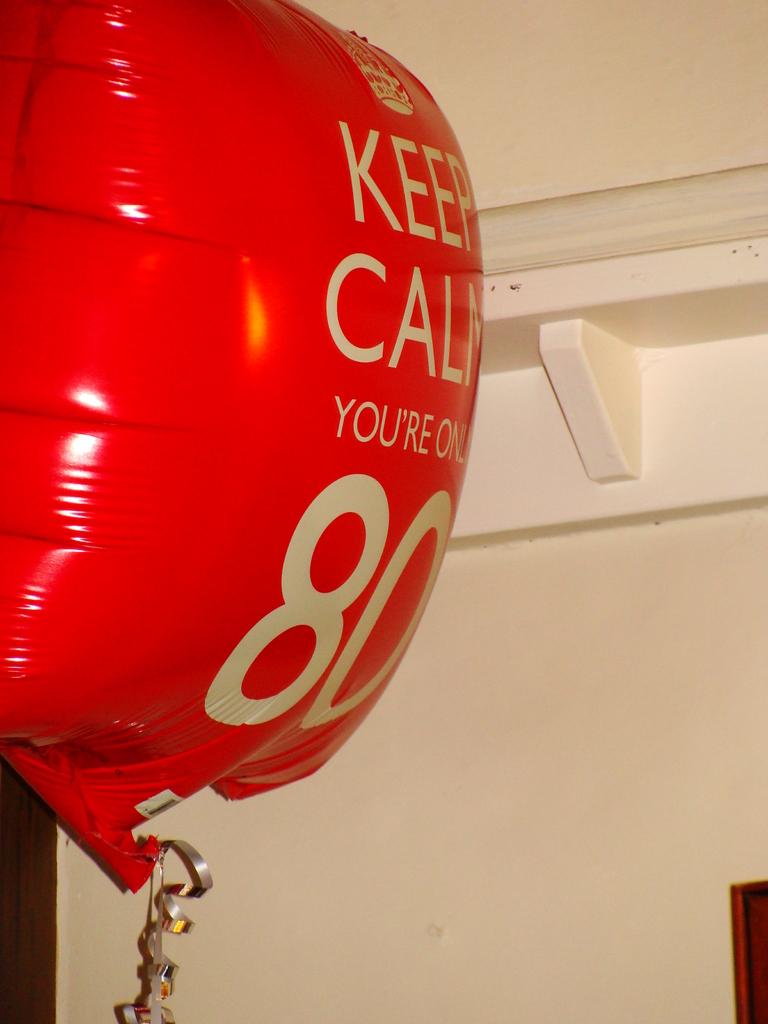How old is the person this balloon is for?
Your answer should be very brief. 80. What does it say to do about turning 80?
Keep it short and to the point. Keep calm. 